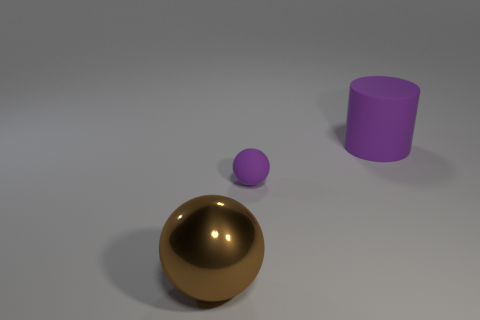Add 1 tiny objects. How many objects exist? 4 Subtract all spheres. How many objects are left? 1 Subtract all spheres. Subtract all metallic balls. How many objects are left? 0 Add 3 purple cylinders. How many purple cylinders are left? 4 Add 2 big purple matte objects. How many big purple matte objects exist? 3 Subtract 0 red spheres. How many objects are left? 3 